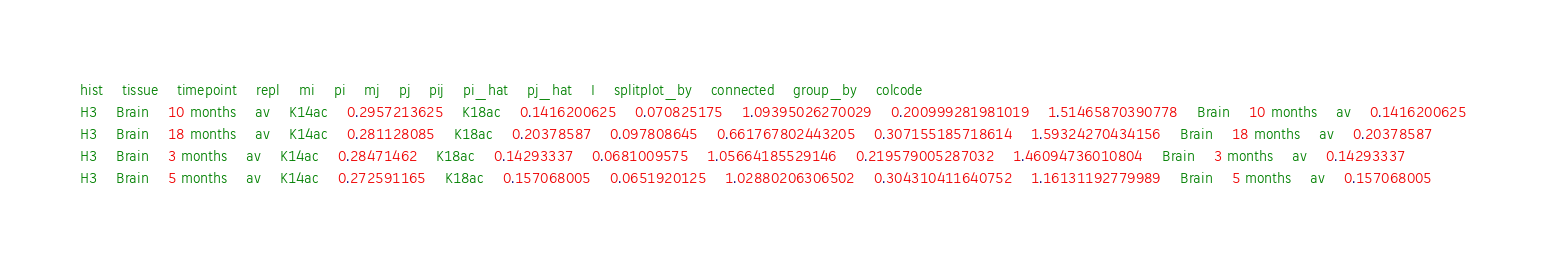<code> <loc_0><loc_0><loc_500><loc_500><_SQL_>hist	tissue	timepoint	repl	mi	pi	mj	pj	pij	pi_hat	pj_hat	I	splitplot_by	connected	group_by	colcode
H3	Brain	10 months	av	K14ac	0.2957213625	K18ac	0.1416200625	0.070825175	1.09395026270029	0.200999281981019	1.51465870390778	Brain	10 months	av	0.1416200625
H3	Brain	18 months	av	K14ac	0.281128085	K18ac	0.20378587	0.097808645	0.661767802443205	0.307155185718614	1.59324270434156	Brain	18 months	av	0.20378587
H3	Brain	3 months	av	K14ac	0.28471462	K18ac	0.14293337	0.0681009575	1.05664185529146	0.219579005287032	1.46094736010804	Brain	3 months	av	0.14293337
H3	Brain	5 months	av	K14ac	0.272591165	K18ac	0.157068005	0.0651920125	1.02880206306502	0.304310411640752	1.16131192779989	Brain	5 months	av	0.157068005</code> 